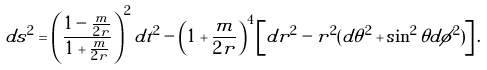<formula> <loc_0><loc_0><loc_500><loc_500>d s ^ { 2 } = \left ( \frac { 1 - \frac { m } { 2 r } } { 1 + \frac { m } { 2 r } } \right ) ^ { 2 } d t ^ { 2 } - \left ( 1 + \frac { m } { 2 r } \right ) ^ { 4 } \left [ d r ^ { 2 } - r ^ { 2 } ( d \theta ^ { 2 } + \sin ^ { 2 } \theta d \phi ^ { 2 } ) \right ] .</formula> 